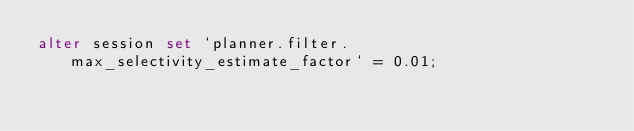<code> <loc_0><loc_0><loc_500><loc_500><_SQL_>alter session set `planner.filter.max_selectivity_estimate_factor` = 0.01;</code> 